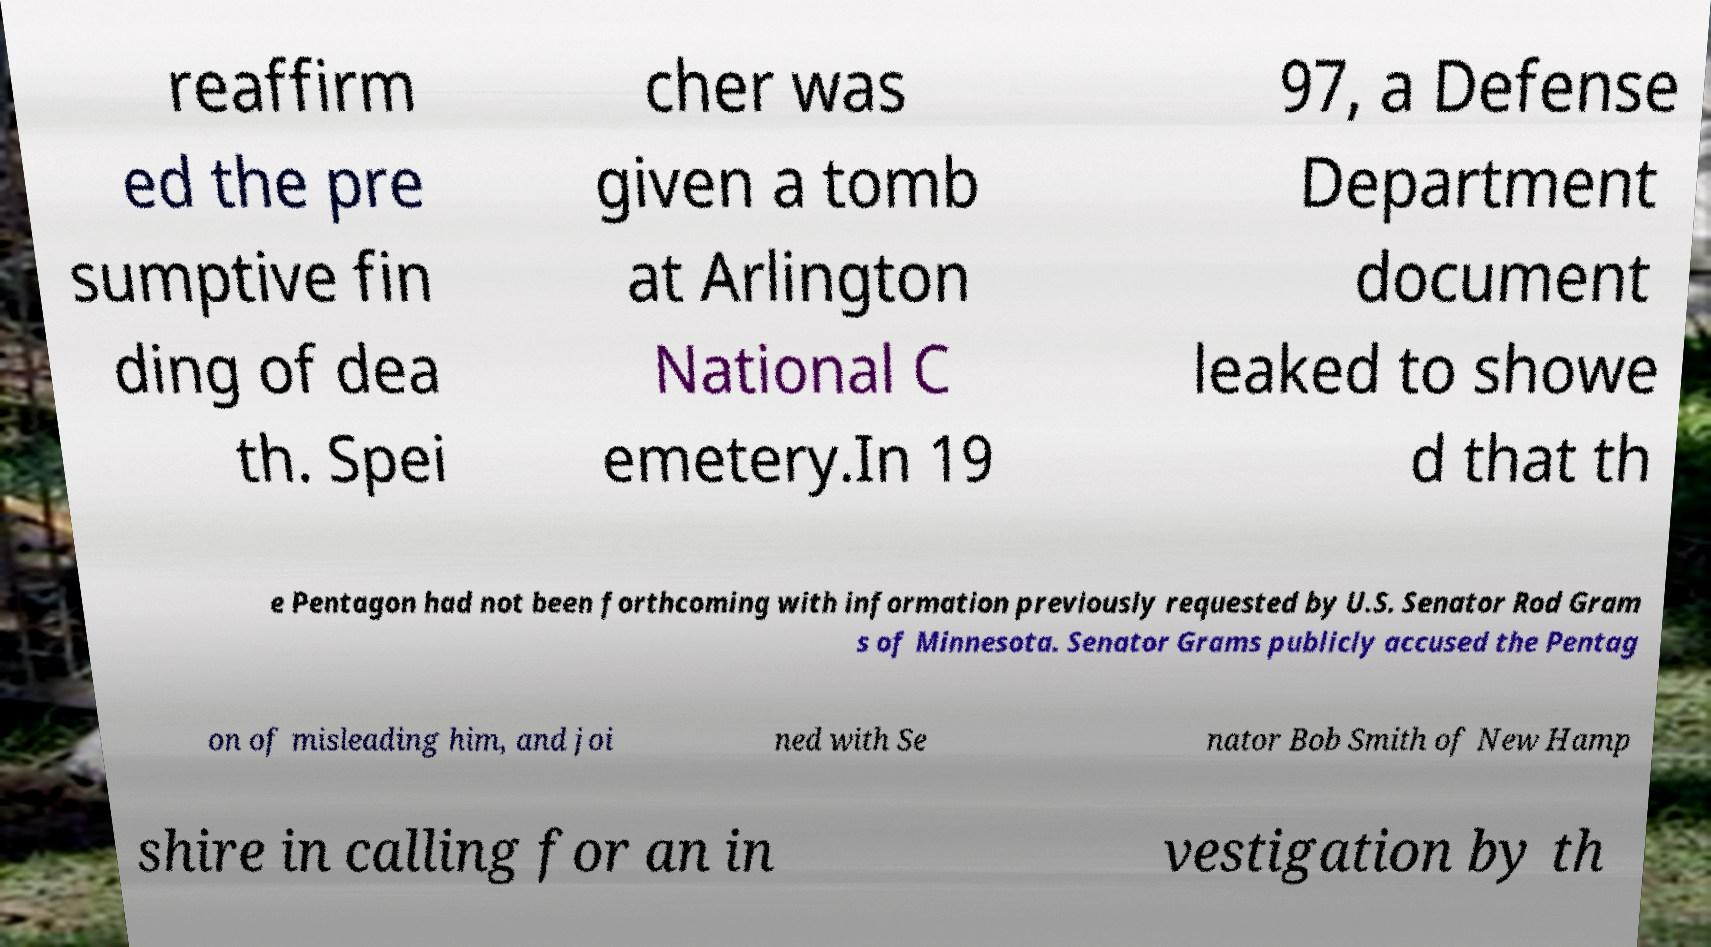For documentation purposes, I need the text within this image transcribed. Could you provide that? reaffirm ed the pre sumptive fin ding of dea th. Spei cher was given a tomb at Arlington National C emetery.In 19 97, a Defense Department document leaked to showe d that th e Pentagon had not been forthcoming with information previously requested by U.S. Senator Rod Gram s of Minnesota. Senator Grams publicly accused the Pentag on of misleading him, and joi ned with Se nator Bob Smith of New Hamp shire in calling for an in vestigation by th 